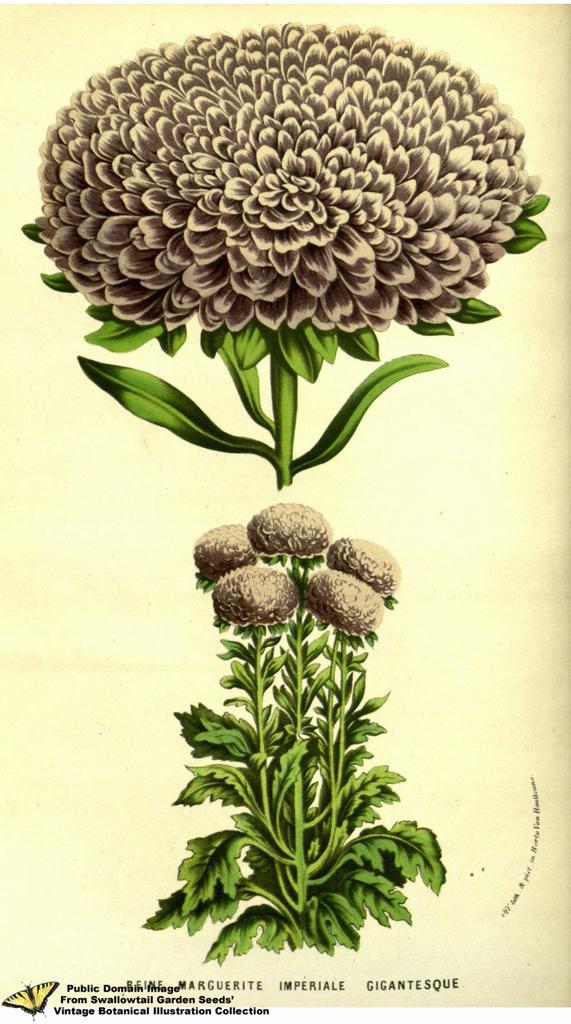Describe this image in one or two sentences. In this picture there is a painting of flowers, there are flowers on the plant. At the bottom of the image there is a text and there is a painting of butterfly. 